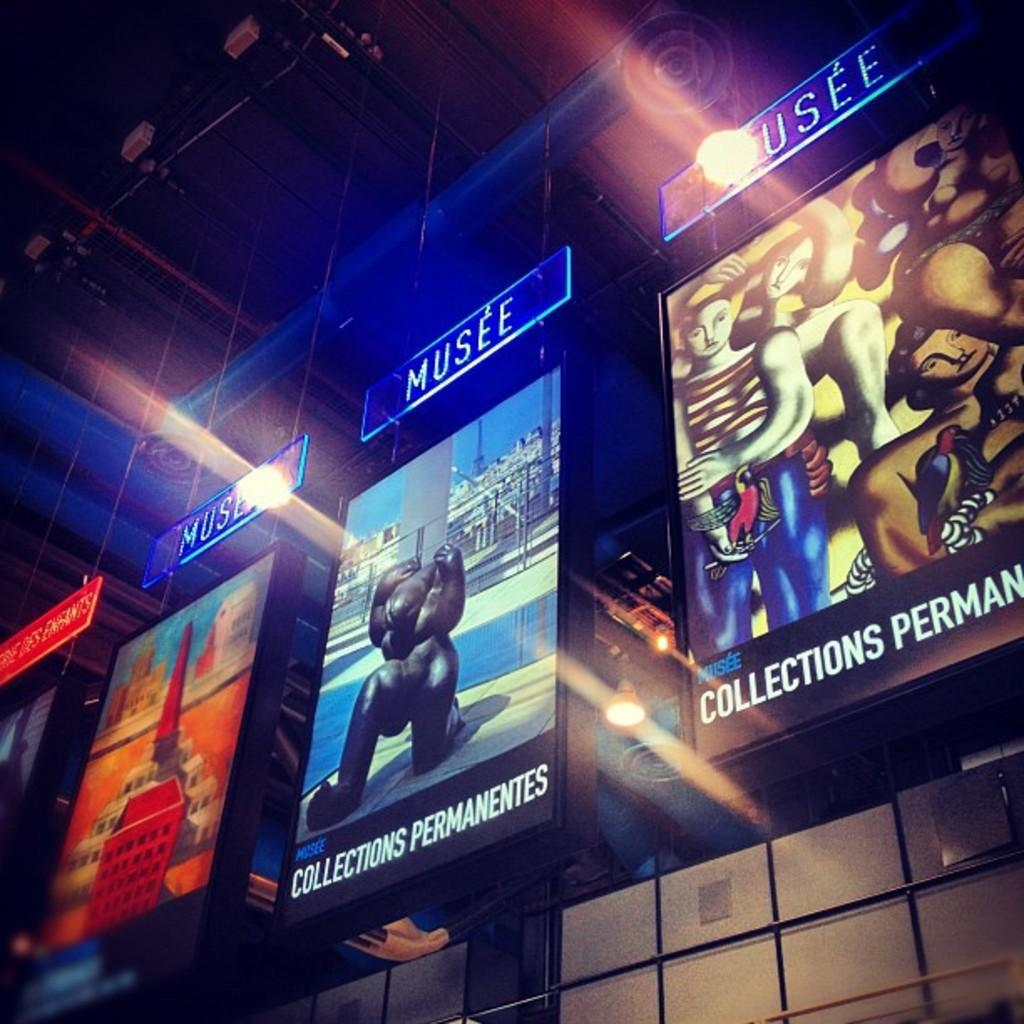Provide a one-sentence caption for the provided image. Colorful advertisements of artworks are encased in displays that says "MUSEE" on top. 